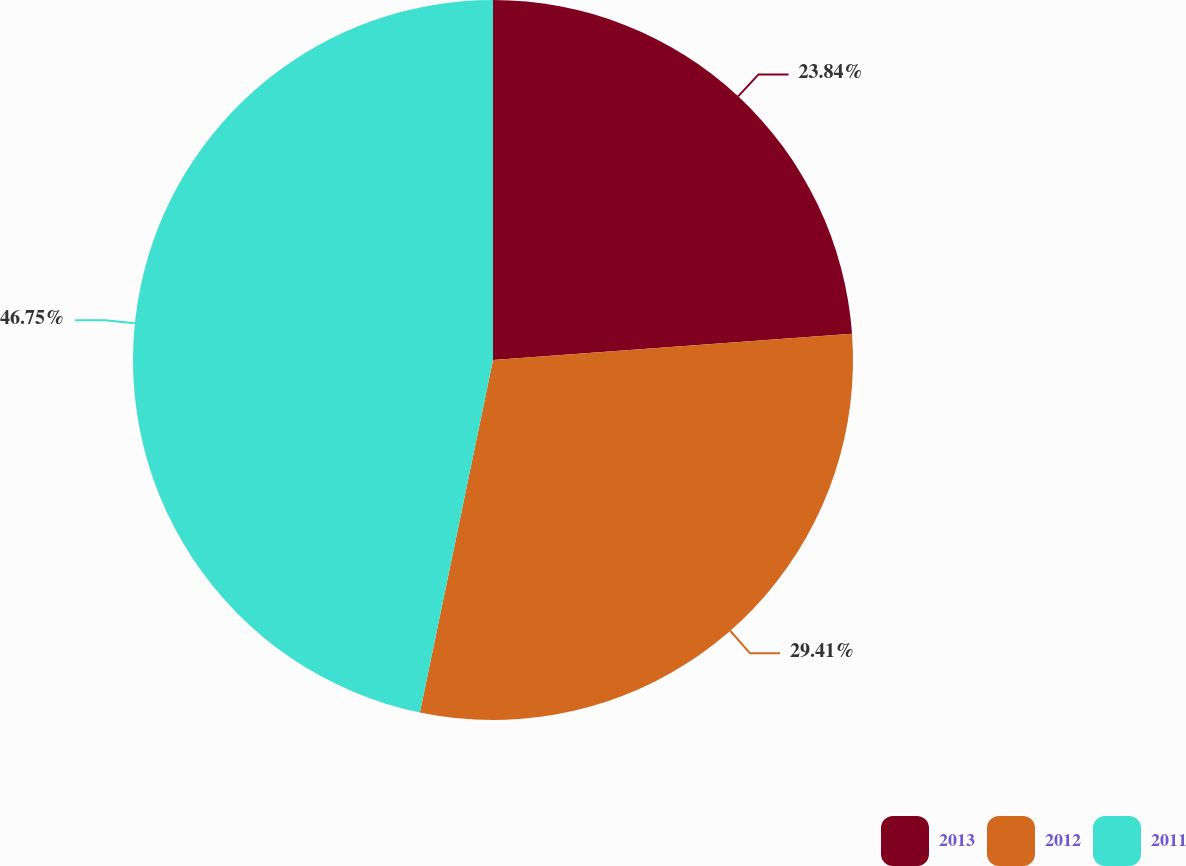<chart> <loc_0><loc_0><loc_500><loc_500><pie_chart><fcel>2013<fcel>2012<fcel>2011<nl><fcel>23.84%<fcel>29.41%<fcel>46.74%<nl></chart> 